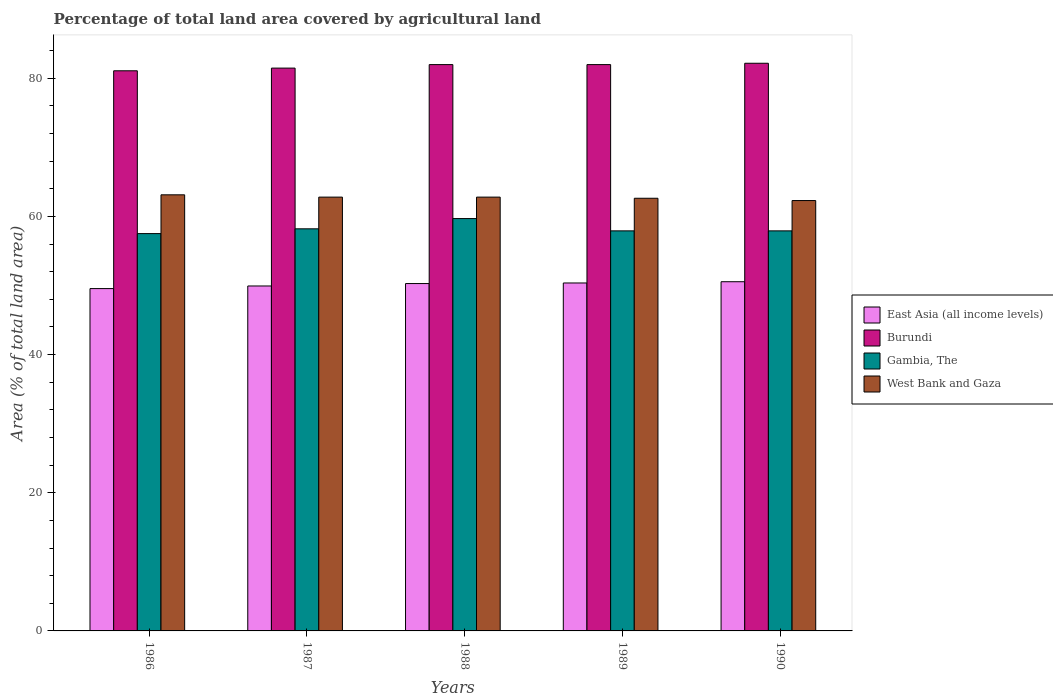How many different coloured bars are there?
Ensure brevity in your answer.  4. How many bars are there on the 4th tick from the right?
Give a very brief answer. 4. In how many cases, is the number of bars for a given year not equal to the number of legend labels?
Make the answer very short. 0. What is the percentage of agricultural land in Burundi in 1986?
Provide a succinct answer. 81.07. Across all years, what is the maximum percentage of agricultural land in East Asia (all income levels)?
Give a very brief answer. 50.54. Across all years, what is the minimum percentage of agricultural land in West Bank and Gaza?
Provide a succinct answer. 62.29. In which year was the percentage of agricultural land in Burundi minimum?
Your response must be concise. 1986. What is the total percentage of agricultural land in East Asia (all income levels) in the graph?
Keep it short and to the point. 250.66. What is the difference between the percentage of agricultural land in West Bank and Gaza in 1988 and that in 1990?
Offer a terse response. 0.5. What is the difference between the percentage of agricultural land in Gambia, The in 1987 and the percentage of agricultural land in West Bank and Gaza in 1989?
Give a very brief answer. -4.42. What is the average percentage of agricultural land in Burundi per year?
Provide a short and direct response. 81.73. In the year 1986, what is the difference between the percentage of agricultural land in West Bank and Gaza and percentage of agricultural land in Gambia, The?
Your response must be concise. 5.61. In how many years, is the percentage of agricultural land in East Asia (all income levels) greater than 60 %?
Make the answer very short. 0. What is the ratio of the percentage of agricultural land in Gambia, The in 1988 to that in 1989?
Ensure brevity in your answer.  1.03. Is the percentage of agricultural land in Burundi in 1986 less than that in 1988?
Provide a short and direct response. Yes. What is the difference between the highest and the second highest percentage of agricultural land in Burundi?
Offer a terse response. 0.19. What is the difference between the highest and the lowest percentage of agricultural land in East Asia (all income levels)?
Give a very brief answer. 0.99. Is it the case that in every year, the sum of the percentage of agricultural land in East Asia (all income levels) and percentage of agricultural land in West Bank and Gaza is greater than the sum of percentage of agricultural land in Burundi and percentage of agricultural land in Gambia, The?
Offer a terse response. No. What does the 1st bar from the left in 1986 represents?
Keep it short and to the point. East Asia (all income levels). What does the 4th bar from the right in 1990 represents?
Make the answer very short. East Asia (all income levels). Are all the bars in the graph horizontal?
Your response must be concise. No. Are the values on the major ticks of Y-axis written in scientific E-notation?
Your answer should be very brief. No. Does the graph contain any zero values?
Keep it short and to the point. No. Does the graph contain grids?
Offer a terse response. No. Where does the legend appear in the graph?
Give a very brief answer. Center right. What is the title of the graph?
Your response must be concise. Percentage of total land area covered by agricultural land. What is the label or title of the X-axis?
Offer a very short reply. Years. What is the label or title of the Y-axis?
Offer a very short reply. Area (% of total land area). What is the Area (% of total land area) in East Asia (all income levels) in 1986?
Your answer should be compact. 49.55. What is the Area (% of total land area) of Burundi in 1986?
Your answer should be compact. 81.07. What is the Area (% of total land area) of Gambia, The in 1986?
Provide a short and direct response. 57.51. What is the Area (% of total land area) in West Bank and Gaza in 1986?
Offer a terse response. 63.12. What is the Area (% of total land area) of East Asia (all income levels) in 1987?
Offer a terse response. 49.93. What is the Area (% of total land area) of Burundi in 1987?
Ensure brevity in your answer.  81.46. What is the Area (% of total land area) in Gambia, The in 1987?
Make the answer very short. 58.2. What is the Area (% of total land area) in West Bank and Gaza in 1987?
Offer a terse response. 62.79. What is the Area (% of total land area) in East Asia (all income levels) in 1988?
Offer a very short reply. 50.28. What is the Area (% of total land area) of Burundi in 1988?
Your response must be concise. 81.97. What is the Area (% of total land area) in Gambia, The in 1988?
Your answer should be compact. 59.68. What is the Area (% of total land area) in West Bank and Gaza in 1988?
Your answer should be very brief. 62.79. What is the Area (% of total land area) of East Asia (all income levels) in 1989?
Make the answer very short. 50.36. What is the Area (% of total land area) of Burundi in 1989?
Your response must be concise. 81.97. What is the Area (% of total land area) of Gambia, The in 1989?
Provide a short and direct response. 57.91. What is the Area (% of total land area) of West Bank and Gaza in 1989?
Provide a succinct answer. 62.62. What is the Area (% of total land area) of East Asia (all income levels) in 1990?
Provide a succinct answer. 50.54. What is the Area (% of total land area) of Burundi in 1990?
Keep it short and to the point. 82.17. What is the Area (% of total land area) of Gambia, The in 1990?
Give a very brief answer. 57.91. What is the Area (% of total land area) in West Bank and Gaza in 1990?
Your answer should be compact. 62.29. Across all years, what is the maximum Area (% of total land area) in East Asia (all income levels)?
Your answer should be compact. 50.54. Across all years, what is the maximum Area (% of total land area) in Burundi?
Provide a short and direct response. 82.17. Across all years, what is the maximum Area (% of total land area) in Gambia, The?
Give a very brief answer. 59.68. Across all years, what is the maximum Area (% of total land area) of West Bank and Gaza?
Your response must be concise. 63.12. Across all years, what is the minimum Area (% of total land area) of East Asia (all income levels)?
Give a very brief answer. 49.55. Across all years, what is the minimum Area (% of total land area) in Burundi?
Provide a succinct answer. 81.07. Across all years, what is the minimum Area (% of total land area) in Gambia, The?
Keep it short and to the point. 57.51. Across all years, what is the minimum Area (% of total land area) in West Bank and Gaza?
Offer a terse response. 62.29. What is the total Area (% of total land area) in East Asia (all income levels) in the graph?
Provide a short and direct response. 250.66. What is the total Area (% of total land area) in Burundi in the graph?
Your answer should be very brief. 408.64. What is the total Area (% of total land area) in Gambia, The in the graph?
Offer a terse response. 291.21. What is the total Area (% of total land area) of West Bank and Gaza in the graph?
Your response must be concise. 313.62. What is the difference between the Area (% of total land area) of East Asia (all income levels) in 1986 and that in 1987?
Offer a terse response. -0.38. What is the difference between the Area (% of total land area) of Burundi in 1986 and that in 1987?
Keep it short and to the point. -0.39. What is the difference between the Area (% of total land area) of Gambia, The in 1986 and that in 1987?
Provide a succinct answer. -0.69. What is the difference between the Area (% of total land area) of West Bank and Gaza in 1986 and that in 1987?
Ensure brevity in your answer.  0.33. What is the difference between the Area (% of total land area) in East Asia (all income levels) in 1986 and that in 1988?
Your answer should be very brief. -0.73. What is the difference between the Area (% of total land area) in Burundi in 1986 and that in 1988?
Your answer should be compact. -0.9. What is the difference between the Area (% of total land area) in Gambia, The in 1986 and that in 1988?
Keep it short and to the point. -2.17. What is the difference between the Area (% of total land area) in West Bank and Gaza in 1986 and that in 1988?
Make the answer very short. 0.33. What is the difference between the Area (% of total land area) in East Asia (all income levels) in 1986 and that in 1989?
Your answer should be very brief. -0.81. What is the difference between the Area (% of total land area) in Burundi in 1986 and that in 1989?
Ensure brevity in your answer.  -0.9. What is the difference between the Area (% of total land area) of Gambia, The in 1986 and that in 1989?
Provide a short and direct response. -0.4. What is the difference between the Area (% of total land area) in West Bank and Gaza in 1986 and that in 1989?
Your answer should be very brief. 0.5. What is the difference between the Area (% of total land area) of East Asia (all income levels) in 1986 and that in 1990?
Your response must be concise. -0.99. What is the difference between the Area (% of total land area) in Burundi in 1986 and that in 1990?
Provide a succinct answer. -1.09. What is the difference between the Area (% of total land area) in Gambia, The in 1986 and that in 1990?
Give a very brief answer. -0.4. What is the difference between the Area (% of total land area) of West Bank and Gaza in 1986 and that in 1990?
Your answer should be compact. 0.83. What is the difference between the Area (% of total land area) in East Asia (all income levels) in 1987 and that in 1988?
Make the answer very short. -0.35. What is the difference between the Area (% of total land area) in Burundi in 1987 and that in 1988?
Offer a very short reply. -0.51. What is the difference between the Area (% of total land area) of Gambia, The in 1987 and that in 1988?
Provide a short and direct response. -1.48. What is the difference between the Area (% of total land area) in West Bank and Gaza in 1987 and that in 1988?
Provide a succinct answer. 0. What is the difference between the Area (% of total land area) of East Asia (all income levels) in 1987 and that in 1989?
Provide a short and direct response. -0.43. What is the difference between the Area (% of total land area) of Burundi in 1987 and that in 1989?
Provide a short and direct response. -0.51. What is the difference between the Area (% of total land area) in Gambia, The in 1987 and that in 1989?
Make the answer very short. 0.3. What is the difference between the Area (% of total land area) in West Bank and Gaza in 1987 and that in 1989?
Your answer should be very brief. 0.17. What is the difference between the Area (% of total land area) in East Asia (all income levels) in 1987 and that in 1990?
Provide a short and direct response. -0.62. What is the difference between the Area (% of total land area) of Burundi in 1987 and that in 1990?
Give a very brief answer. -0.7. What is the difference between the Area (% of total land area) in Gambia, The in 1987 and that in 1990?
Offer a terse response. 0.3. What is the difference between the Area (% of total land area) of West Bank and Gaza in 1987 and that in 1990?
Provide a succinct answer. 0.5. What is the difference between the Area (% of total land area) in East Asia (all income levels) in 1988 and that in 1989?
Give a very brief answer. -0.08. What is the difference between the Area (% of total land area) in Burundi in 1988 and that in 1989?
Make the answer very short. 0. What is the difference between the Area (% of total land area) of Gambia, The in 1988 and that in 1989?
Keep it short and to the point. 1.78. What is the difference between the Area (% of total land area) in West Bank and Gaza in 1988 and that in 1989?
Give a very brief answer. 0.17. What is the difference between the Area (% of total land area) of East Asia (all income levels) in 1988 and that in 1990?
Give a very brief answer. -0.26. What is the difference between the Area (% of total land area) in Burundi in 1988 and that in 1990?
Give a very brief answer. -0.19. What is the difference between the Area (% of total land area) of Gambia, The in 1988 and that in 1990?
Make the answer very short. 1.78. What is the difference between the Area (% of total land area) of West Bank and Gaza in 1988 and that in 1990?
Ensure brevity in your answer.  0.5. What is the difference between the Area (% of total land area) of East Asia (all income levels) in 1989 and that in 1990?
Provide a short and direct response. -0.18. What is the difference between the Area (% of total land area) of Burundi in 1989 and that in 1990?
Your answer should be compact. -0.19. What is the difference between the Area (% of total land area) of West Bank and Gaza in 1989 and that in 1990?
Ensure brevity in your answer.  0.33. What is the difference between the Area (% of total land area) of East Asia (all income levels) in 1986 and the Area (% of total land area) of Burundi in 1987?
Your answer should be very brief. -31.91. What is the difference between the Area (% of total land area) of East Asia (all income levels) in 1986 and the Area (% of total land area) of Gambia, The in 1987?
Give a very brief answer. -8.65. What is the difference between the Area (% of total land area) of East Asia (all income levels) in 1986 and the Area (% of total land area) of West Bank and Gaza in 1987?
Ensure brevity in your answer.  -13.24. What is the difference between the Area (% of total land area) in Burundi in 1986 and the Area (% of total land area) in Gambia, The in 1987?
Your answer should be compact. 22.87. What is the difference between the Area (% of total land area) in Burundi in 1986 and the Area (% of total land area) in West Bank and Gaza in 1987?
Your answer should be compact. 18.28. What is the difference between the Area (% of total land area) in Gambia, The in 1986 and the Area (% of total land area) in West Bank and Gaza in 1987?
Ensure brevity in your answer.  -5.28. What is the difference between the Area (% of total land area) of East Asia (all income levels) in 1986 and the Area (% of total land area) of Burundi in 1988?
Your answer should be compact. -32.42. What is the difference between the Area (% of total land area) of East Asia (all income levels) in 1986 and the Area (% of total land area) of Gambia, The in 1988?
Your response must be concise. -10.13. What is the difference between the Area (% of total land area) in East Asia (all income levels) in 1986 and the Area (% of total land area) in West Bank and Gaza in 1988?
Make the answer very short. -13.24. What is the difference between the Area (% of total land area) of Burundi in 1986 and the Area (% of total land area) of Gambia, The in 1988?
Provide a succinct answer. 21.39. What is the difference between the Area (% of total land area) of Burundi in 1986 and the Area (% of total land area) of West Bank and Gaza in 1988?
Offer a very short reply. 18.28. What is the difference between the Area (% of total land area) in Gambia, The in 1986 and the Area (% of total land area) in West Bank and Gaza in 1988?
Your answer should be very brief. -5.28. What is the difference between the Area (% of total land area) of East Asia (all income levels) in 1986 and the Area (% of total land area) of Burundi in 1989?
Offer a terse response. -32.42. What is the difference between the Area (% of total land area) of East Asia (all income levels) in 1986 and the Area (% of total land area) of Gambia, The in 1989?
Your response must be concise. -8.35. What is the difference between the Area (% of total land area) in East Asia (all income levels) in 1986 and the Area (% of total land area) in West Bank and Gaza in 1989?
Give a very brief answer. -13.07. What is the difference between the Area (% of total land area) in Burundi in 1986 and the Area (% of total land area) in Gambia, The in 1989?
Give a very brief answer. 23.17. What is the difference between the Area (% of total land area) in Burundi in 1986 and the Area (% of total land area) in West Bank and Gaza in 1989?
Your answer should be compact. 18.45. What is the difference between the Area (% of total land area) of Gambia, The in 1986 and the Area (% of total land area) of West Bank and Gaza in 1989?
Your response must be concise. -5.11. What is the difference between the Area (% of total land area) of East Asia (all income levels) in 1986 and the Area (% of total land area) of Burundi in 1990?
Offer a very short reply. -32.61. What is the difference between the Area (% of total land area) in East Asia (all income levels) in 1986 and the Area (% of total land area) in Gambia, The in 1990?
Keep it short and to the point. -8.35. What is the difference between the Area (% of total land area) of East Asia (all income levels) in 1986 and the Area (% of total land area) of West Bank and Gaza in 1990?
Your answer should be compact. -12.74. What is the difference between the Area (% of total land area) of Burundi in 1986 and the Area (% of total land area) of Gambia, The in 1990?
Provide a succinct answer. 23.17. What is the difference between the Area (% of total land area) in Burundi in 1986 and the Area (% of total land area) in West Bank and Gaza in 1990?
Offer a terse response. 18.78. What is the difference between the Area (% of total land area) in Gambia, The in 1986 and the Area (% of total land area) in West Bank and Gaza in 1990?
Ensure brevity in your answer.  -4.78. What is the difference between the Area (% of total land area) in East Asia (all income levels) in 1987 and the Area (% of total land area) in Burundi in 1988?
Offer a very short reply. -32.04. What is the difference between the Area (% of total land area) in East Asia (all income levels) in 1987 and the Area (% of total land area) in Gambia, The in 1988?
Your answer should be compact. -9.76. What is the difference between the Area (% of total land area) in East Asia (all income levels) in 1987 and the Area (% of total land area) in West Bank and Gaza in 1988?
Offer a very short reply. -12.86. What is the difference between the Area (% of total land area) of Burundi in 1987 and the Area (% of total land area) of Gambia, The in 1988?
Your response must be concise. 21.78. What is the difference between the Area (% of total land area) of Burundi in 1987 and the Area (% of total land area) of West Bank and Gaza in 1988?
Offer a very short reply. 18.67. What is the difference between the Area (% of total land area) of Gambia, The in 1987 and the Area (% of total land area) of West Bank and Gaza in 1988?
Make the answer very short. -4.59. What is the difference between the Area (% of total land area) in East Asia (all income levels) in 1987 and the Area (% of total land area) in Burundi in 1989?
Offer a terse response. -32.04. What is the difference between the Area (% of total land area) in East Asia (all income levels) in 1987 and the Area (% of total land area) in Gambia, The in 1989?
Make the answer very short. -7.98. What is the difference between the Area (% of total land area) in East Asia (all income levels) in 1987 and the Area (% of total land area) in West Bank and Gaza in 1989?
Your answer should be compact. -12.7. What is the difference between the Area (% of total land area) of Burundi in 1987 and the Area (% of total land area) of Gambia, The in 1989?
Ensure brevity in your answer.  23.56. What is the difference between the Area (% of total land area) of Burundi in 1987 and the Area (% of total land area) of West Bank and Gaza in 1989?
Offer a very short reply. 18.84. What is the difference between the Area (% of total land area) in Gambia, The in 1987 and the Area (% of total land area) in West Bank and Gaza in 1989?
Provide a short and direct response. -4.42. What is the difference between the Area (% of total land area) in East Asia (all income levels) in 1987 and the Area (% of total land area) in Burundi in 1990?
Keep it short and to the point. -32.24. What is the difference between the Area (% of total land area) in East Asia (all income levels) in 1987 and the Area (% of total land area) in Gambia, The in 1990?
Offer a very short reply. -7.98. What is the difference between the Area (% of total land area) of East Asia (all income levels) in 1987 and the Area (% of total land area) of West Bank and Gaza in 1990?
Offer a terse response. -12.36. What is the difference between the Area (% of total land area) in Burundi in 1987 and the Area (% of total land area) in Gambia, The in 1990?
Make the answer very short. 23.56. What is the difference between the Area (% of total land area) of Burundi in 1987 and the Area (% of total land area) of West Bank and Gaza in 1990?
Give a very brief answer. 19.17. What is the difference between the Area (% of total land area) of Gambia, The in 1987 and the Area (% of total land area) of West Bank and Gaza in 1990?
Offer a very short reply. -4.09. What is the difference between the Area (% of total land area) of East Asia (all income levels) in 1988 and the Area (% of total land area) of Burundi in 1989?
Ensure brevity in your answer.  -31.69. What is the difference between the Area (% of total land area) in East Asia (all income levels) in 1988 and the Area (% of total land area) in Gambia, The in 1989?
Keep it short and to the point. -7.63. What is the difference between the Area (% of total land area) in East Asia (all income levels) in 1988 and the Area (% of total land area) in West Bank and Gaza in 1989?
Your answer should be compact. -12.34. What is the difference between the Area (% of total land area) in Burundi in 1988 and the Area (% of total land area) in Gambia, The in 1989?
Your answer should be very brief. 24.07. What is the difference between the Area (% of total land area) of Burundi in 1988 and the Area (% of total land area) of West Bank and Gaza in 1989?
Provide a short and direct response. 19.35. What is the difference between the Area (% of total land area) in Gambia, The in 1988 and the Area (% of total land area) in West Bank and Gaza in 1989?
Make the answer very short. -2.94. What is the difference between the Area (% of total land area) in East Asia (all income levels) in 1988 and the Area (% of total land area) in Burundi in 1990?
Provide a succinct answer. -31.89. What is the difference between the Area (% of total land area) in East Asia (all income levels) in 1988 and the Area (% of total land area) in Gambia, The in 1990?
Keep it short and to the point. -7.63. What is the difference between the Area (% of total land area) of East Asia (all income levels) in 1988 and the Area (% of total land area) of West Bank and Gaza in 1990?
Your response must be concise. -12.01. What is the difference between the Area (% of total land area) in Burundi in 1988 and the Area (% of total land area) in Gambia, The in 1990?
Offer a terse response. 24.07. What is the difference between the Area (% of total land area) of Burundi in 1988 and the Area (% of total land area) of West Bank and Gaza in 1990?
Ensure brevity in your answer.  19.68. What is the difference between the Area (% of total land area) of Gambia, The in 1988 and the Area (% of total land area) of West Bank and Gaza in 1990?
Offer a very short reply. -2.61. What is the difference between the Area (% of total land area) in East Asia (all income levels) in 1989 and the Area (% of total land area) in Burundi in 1990?
Make the answer very short. -31.8. What is the difference between the Area (% of total land area) in East Asia (all income levels) in 1989 and the Area (% of total land area) in Gambia, The in 1990?
Keep it short and to the point. -7.54. What is the difference between the Area (% of total land area) in East Asia (all income levels) in 1989 and the Area (% of total land area) in West Bank and Gaza in 1990?
Offer a terse response. -11.93. What is the difference between the Area (% of total land area) of Burundi in 1989 and the Area (% of total land area) of Gambia, The in 1990?
Give a very brief answer. 24.07. What is the difference between the Area (% of total land area) in Burundi in 1989 and the Area (% of total land area) in West Bank and Gaza in 1990?
Offer a very short reply. 19.68. What is the difference between the Area (% of total land area) of Gambia, The in 1989 and the Area (% of total land area) of West Bank and Gaza in 1990?
Provide a succinct answer. -4.39. What is the average Area (% of total land area) in East Asia (all income levels) per year?
Give a very brief answer. 50.13. What is the average Area (% of total land area) in Burundi per year?
Provide a succinct answer. 81.73. What is the average Area (% of total land area) of Gambia, The per year?
Give a very brief answer. 58.24. What is the average Area (% of total land area) of West Bank and Gaza per year?
Your response must be concise. 62.72. In the year 1986, what is the difference between the Area (% of total land area) in East Asia (all income levels) and Area (% of total land area) in Burundi?
Give a very brief answer. -31.52. In the year 1986, what is the difference between the Area (% of total land area) of East Asia (all income levels) and Area (% of total land area) of Gambia, The?
Offer a very short reply. -7.96. In the year 1986, what is the difference between the Area (% of total land area) of East Asia (all income levels) and Area (% of total land area) of West Bank and Gaza?
Offer a terse response. -13.57. In the year 1986, what is the difference between the Area (% of total land area) in Burundi and Area (% of total land area) in Gambia, The?
Provide a succinct answer. 23.56. In the year 1986, what is the difference between the Area (% of total land area) in Burundi and Area (% of total land area) in West Bank and Gaza?
Ensure brevity in your answer.  17.95. In the year 1986, what is the difference between the Area (% of total land area) of Gambia, The and Area (% of total land area) of West Bank and Gaza?
Ensure brevity in your answer.  -5.61. In the year 1987, what is the difference between the Area (% of total land area) in East Asia (all income levels) and Area (% of total land area) in Burundi?
Your answer should be compact. -31.54. In the year 1987, what is the difference between the Area (% of total land area) in East Asia (all income levels) and Area (% of total land area) in Gambia, The?
Give a very brief answer. -8.27. In the year 1987, what is the difference between the Area (% of total land area) of East Asia (all income levels) and Area (% of total land area) of West Bank and Gaza?
Your answer should be very brief. -12.86. In the year 1987, what is the difference between the Area (% of total land area) in Burundi and Area (% of total land area) in Gambia, The?
Ensure brevity in your answer.  23.26. In the year 1987, what is the difference between the Area (% of total land area) in Burundi and Area (% of total land area) in West Bank and Gaza?
Make the answer very short. 18.67. In the year 1987, what is the difference between the Area (% of total land area) in Gambia, The and Area (% of total land area) in West Bank and Gaza?
Your answer should be very brief. -4.59. In the year 1988, what is the difference between the Area (% of total land area) of East Asia (all income levels) and Area (% of total land area) of Burundi?
Provide a succinct answer. -31.69. In the year 1988, what is the difference between the Area (% of total land area) of East Asia (all income levels) and Area (% of total land area) of Gambia, The?
Make the answer very short. -9.4. In the year 1988, what is the difference between the Area (% of total land area) of East Asia (all income levels) and Area (% of total land area) of West Bank and Gaza?
Your answer should be compact. -12.51. In the year 1988, what is the difference between the Area (% of total land area) of Burundi and Area (% of total land area) of Gambia, The?
Offer a terse response. 22.29. In the year 1988, what is the difference between the Area (% of total land area) of Burundi and Area (% of total land area) of West Bank and Gaza?
Provide a succinct answer. 19.18. In the year 1988, what is the difference between the Area (% of total land area) in Gambia, The and Area (% of total land area) in West Bank and Gaza?
Your answer should be very brief. -3.11. In the year 1989, what is the difference between the Area (% of total land area) in East Asia (all income levels) and Area (% of total land area) in Burundi?
Your answer should be compact. -31.61. In the year 1989, what is the difference between the Area (% of total land area) in East Asia (all income levels) and Area (% of total land area) in Gambia, The?
Your answer should be very brief. -7.54. In the year 1989, what is the difference between the Area (% of total land area) in East Asia (all income levels) and Area (% of total land area) in West Bank and Gaza?
Provide a succinct answer. -12.26. In the year 1989, what is the difference between the Area (% of total land area) of Burundi and Area (% of total land area) of Gambia, The?
Provide a short and direct response. 24.07. In the year 1989, what is the difference between the Area (% of total land area) in Burundi and Area (% of total land area) in West Bank and Gaza?
Keep it short and to the point. 19.35. In the year 1989, what is the difference between the Area (% of total land area) of Gambia, The and Area (% of total land area) of West Bank and Gaza?
Provide a short and direct response. -4.72. In the year 1990, what is the difference between the Area (% of total land area) in East Asia (all income levels) and Area (% of total land area) in Burundi?
Ensure brevity in your answer.  -31.62. In the year 1990, what is the difference between the Area (% of total land area) of East Asia (all income levels) and Area (% of total land area) of Gambia, The?
Make the answer very short. -7.36. In the year 1990, what is the difference between the Area (% of total land area) in East Asia (all income levels) and Area (% of total land area) in West Bank and Gaza?
Provide a succinct answer. -11.75. In the year 1990, what is the difference between the Area (% of total land area) of Burundi and Area (% of total land area) of Gambia, The?
Offer a terse response. 24.26. In the year 1990, what is the difference between the Area (% of total land area) of Burundi and Area (% of total land area) of West Bank and Gaza?
Make the answer very short. 19.87. In the year 1990, what is the difference between the Area (% of total land area) of Gambia, The and Area (% of total land area) of West Bank and Gaza?
Give a very brief answer. -4.39. What is the ratio of the Area (% of total land area) in East Asia (all income levels) in 1986 to that in 1987?
Ensure brevity in your answer.  0.99. What is the ratio of the Area (% of total land area) of Burundi in 1986 to that in 1987?
Provide a short and direct response. 1. What is the ratio of the Area (% of total land area) in East Asia (all income levels) in 1986 to that in 1988?
Offer a very short reply. 0.99. What is the ratio of the Area (% of total land area) in Burundi in 1986 to that in 1988?
Your response must be concise. 0.99. What is the ratio of the Area (% of total land area) in Gambia, The in 1986 to that in 1988?
Offer a very short reply. 0.96. What is the ratio of the Area (% of total land area) of West Bank and Gaza in 1986 to that in 1988?
Your answer should be very brief. 1.01. What is the ratio of the Area (% of total land area) of East Asia (all income levels) in 1986 to that in 1989?
Give a very brief answer. 0.98. What is the ratio of the Area (% of total land area) in Gambia, The in 1986 to that in 1989?
Ensure brevity in your answer.  0.99. What is the ratio of the Area (% of total land area) in East Asia (all income levels) in 1986 to that in 1990?
Offer a terse response. 0.98. What is the ratio of the Area (% of total land area) in Burundi in 1986 to that in 1990?
Offer a terse response. 0.99. What is the ratio of the Area (% of total land area) of Gambia, The in 1986 to that in 1990?
Give a very brief answer. 0.99. What is the ratio of the Area (% of total land area) of West Bank and Gaza in 1986 to that in 1990?
Ensure brevity in your answer.  1.01. What is the ratio of the Area (% of total land area) in Burundi in 1987 to that in 1988?
Give a very brief answer. 0.99. What is the ratio of the Area (% of total land area) of Gambia, The in 1987 to that in 1988?
Provide a short and direct response. 0.98. What is the ratio of the Area (% of total land area) of West Bank and Gaza in 1987 to that in 1988?
Offer a terse response. 1. What is the ratio of the Area (% of total land area) of East Asia (all income levels) in 1987 to that in 1989?
Keep it short and to the point. 0.99. What is the ratio of the Area (% of total land area) in East Asia (all income levels) in 1987 to that in 1990?
Make the answer very short. 0.99. What is the ratio of the Area (% of total land area) in Burundi in 1987 to that in 1990?
Give a very brief answer. 0.99. What is the ratio of the Area (% of total land area) in Gambia, The in 1987 to that in 1990?
Offer a terse response. 1.01. What is the ratio of the Area (% of total land area) in West Bank and Gaza in 1987 to that in 1990?
Keep it short and to the point. 1.01. What is the ratio of the Area (% of total land area) in Burundi in 1988 to that in 1989?
Your answer should be very brief. 1. What is the ratio of the Area (% of total land area) of Gambia, The in 1988 to that in 1989?
Your answer should be very brief. 1.03. What is the ratio of the Area (% of total land area) in West Bank and Gaza in 1988 to that in 1989?
Offer a terse response. 1. What is the ratio of the Area (% of total land area) in Gambia, The in 1988 to that in 1990?
Offer a very short reply. 1.03. What is the ratio of the Area (% of total land area) of West Bank and Gaza in 1988 to that in 1990?
Your answer should be compact. 1.01. What is the ratio of the Area (% of total land area) in East Asia (all income levels) in 1989 to that in 1990?
Keep it short and to the point. 1. What is the ratio of the Area (% of total land area) in Burundi in 1989 to that in 1990?
Provide a short and direct response. 1. What is the difference between the highest and the second highest Area (% of total land area) in East Asia (all income levels)?
Your answer should be very brief. 0.18. What is the difference between the highest and the second highest Area (% of total land area) of Burundi?
Your response must be concise. 0.19. What is the difference between the highest and the second highest Area (% of total land area) of Gambia, The?
Your answer should be very brief. 1.48. What is the difference between the highest and the second highest Area (% of total land area) of West Bank and Gaza?
Give a very brief answer. 0.33. What is the difference between the highest and the lowest Area (% of total land area) in East Asia (all income levels)?
Offer a very short reply. 0.99. What is the difference between the highest and the lowest Area (% of total land area) in Burundi?
Make the answer very short. 1.09. What is the difference between the highest and the lowest Area (% of total land area) in Gambia, The?
Give a very brief answer. 2.17. What is the difference between the highest and the lowest Area (% of total land area) of West Bank and Gaza?
Provide a succinct answer. 0.83. 